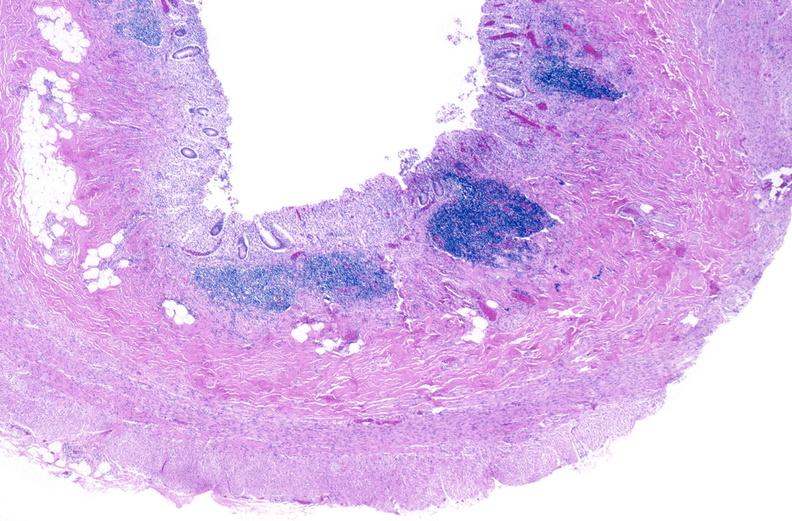what does this image show?
Answer the question using a single word or phrase. Normal appendix 